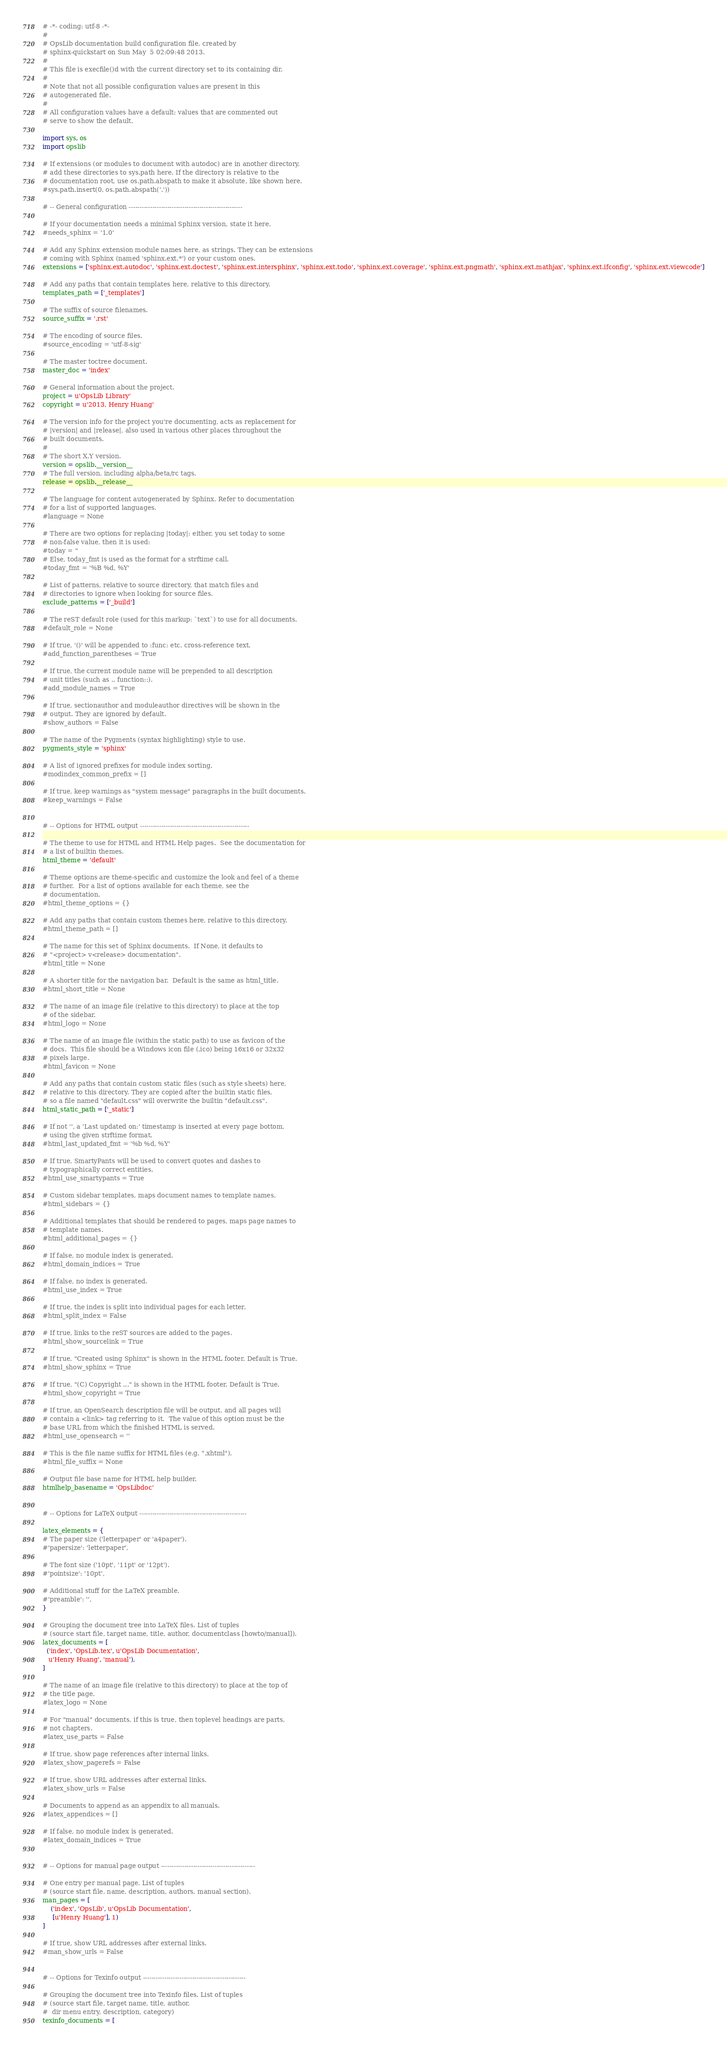<code> <loc_0><loc_0><loc_500><loc_500><_Python_># -*- coding: utf-8 -*-
#
# OpsLib documentation build configuration file, created by
# sphinx-quickstart on Sun May  5 02:09:48 2013.
#
# This file is execfile()d with the current directory set to its containing dir.
#
# Note that not all possible configuration values are present in this
# autogenerated file.
#
# All configuration values have a default; values that are commented out
# serve to show the default.

import sys, os
import opslib

# If extensions (or modules to document with autodoc) are in another directory,
# add these directories to sys.path here. If the directory is relative to the
# documentation root, use os.path.abspath to make it absolute, like shown here.
#sys.path.insert(0, os.path.abspath('.'))

# -- General configuration -----------------------------------------------------

# If your documentation needs a minimal Sphinx version, state it here.
#needs_sphinx = '1.0'

# Add any Sphinx extension module names here, as strings. They can be extensions
# coming with Sphinx (named 'sphinx.ext.*') or your custom ones.
extensions = ['sphinx.ext.autodoc', 'sphinx.ext.doctest', 'sphinx.ext.intersphinx', 'sphinx.ext.todo', 'sphinx.ext.coverage', 'sphinx.ext.pngmath', 'sphinx.ext.mathjax', 'sphinx.ext.ifconfig', 'sphinx.ext.viewcode']

# Add any paths that contain templates here, relative to this directory.
templates_path = ['_templates']

# The suffix of source filenames.
source_suffix = '.rst'

# The encoding of source files.
#source_encoding = 'utf-8-sig'

# The master toctree document.
master_doc = 'index'

# General information about the project.
project = u'OpsLib Library'
copyright = u'2013, Henry Huang'

# The version info for the project you're documenting, acts as replacement for
# |version| and |release|, also used in various other places throughout the
# built documents.
#
# The short X.Y version.
version = opslib.__version__
# The full version, including alpha/beta/rc tags.
release = opslib.__release__

# The language for content autogenerated by Sphinx. Refer to documentation
# for a list of supported languages.
#language = None

# There are two options for replacing |today|: either, you set today to some
# non-false value, then it is used:
#today = ''
# Else, today_fmt is used as the format for a strftime call.
#today_fmt = '%B %d, %Y'

# List of patterns, relative to source directory, that match files and
# directories to ignore when looking for source files.
exclude_patterns = ['_build']

# The reST default role (used for this markup: `text`) to use for all documents.
#default_role = None

# If true, '()' will be appended to :func: etc. cross-reference text.
#add_function_parentheses = True

# If true, the current module name will be prepended to all description
# unit titles (such as .. function::).
#add_module_names = True

# If true, sectionauthor and moduleauthor directives will be shown in the
# output. They are ignored by default.
#show_authors = False

# The name of the Pygments (syntax highlighting) style to use.
pygments_style = 'sphinx'

# A list of ignored prefixes for module index sorting.
#modindex_common_prefix = []

# If true, keep warnings as "system message" paragraphs in the built documents.
#keep_warnings = False


# -- Options for HTML output ---------------------------------------------------

# The theme to use for HTML and HTML Help pages.  See the documentation for
# a list of builtin themes.
html_theme = 'default'

# Theme options are theme-specific and customize the look and feel of a theme
# further.  For a list of options available for each theme, see the
# documentation.
#html_theme_options = {}

# Add any paths that contain custom themes here, relative to this directory.
#html_theme_path = []

# The name for this set of Sphinx documents.  If None, it defaults to
# "<project> v<release> documentation".
#html_title = None

# A shorter title for the navigation bar.  Default is the same as html_title.
#html_short_title = None

# The name of an image file (relative to this directory) to place at the top
# of the sidebar.
#html_logo = None

# The name of an image file (within the static path) to use as favicon of the
# docs.  This file should be a Windows icon file (.ico) being 16x16 or 32x32
# pixels large.
#html_favicon = None

# Add any paths that contain custom static files (such as style sheets) here,
# relative to this directory. They are copied after the builtin static files,
# so a file named "default.css" will overwrite the builtin "default.css".
html_static_path = ['_static']

# If not '', a 'Last updated on:' timestamp is inserted at every page bottom,
# using the given strftime format.
#html_last_updated_fmt = '%b %d, %Y'

# If true, SmartyPants will be used to convert quotes and dashes to
# typographically correct entities.
#html_use_smartypants = True

# Custom sidebar templates, maps document names to template names.
#html_sidebars = {}

# Additional templates that should be rendered to pages, maps page names to
# template names.
#html_additional_pages = {}

# If false, no module index is generated.
#html_domain_indices = True

# If false, no index is generated.
#html_use_index = True

# If true, the index is split into individual pages for each letter.
#html_split_index = False

# If true, links to the reST sources are added to the pages.
#html_show_sourcelink = True

# If true, "Created using Sphinx" is shown in the HTML footer. Default is True.
#html_show_sphinx = True

# If true, "(C) Copyright ..." is shown in the HTML footer. Default is True.
#html_show_copyright = True

# If true, an OpenSearch description file will be output, and all pages will
# contain a <link> tag referring to it.  The value of this option must be the
# base URL from which the finished HTML is served.
#html_use_opensearch = ''

# This is the file name suffix for HTML files (e.g. ".xhtml").
#html_file_suffix = None

# Output file base name for HTML help builder.
htmlhelp_basename = 'OpsLibdoc'


# -- Options for LaTeX output --------------------------------------------------

latex_elements = {
# The paper size ('letterpaper' or 'a4paper').
#'papersize': 'letterpaper',

# The font size ('10pt', '11pt' or '12pt').
#'pointsize': '10pt',

# Additional stuff for the LaTeX preamble.
#'preamble': '',
}

# Grouping the document tree into LaTeX files. List of tuples
# (source start file, target name, title, author, documentclass [howto/manual]).
latex_documents = [
  ('index', 'OpsLib.tex', u'OpsLib Documentation',
   u'Henry Huang', 'manual'),
]

# The name of an image file (relative to this directory) to place at the top of
# the title page.
#latex_logo = None

# For "manual" documents, if this is true, then toplevel headings are parts,
# not chapters.
#latex_use_parts = False

# If true, show page references after internal links.
#latex_show_pagerefs = False

# If true, show URL addresses after external links.
#latex_show_urls = False

# Documents to append as an appendix to all manuals.
#latex_appendices = []

# If false, no module index is generated.
#latex_domain_indices = True


# -- Options for manual page output --------------------------------------------

# One entry per manual page. List of tuples
# (source start file, name, description, authors, manual section).
man_pages = [
    ('index', 'OpsLib', u'OpsLib Documentation',
     [u'Henry Huang'], 1)
]

# If true, show URL addresses after external links.
#man_show_urls = False


# -- Options for Texinfo output ------------------------------------------------

# Grouping the document tree into Texinfo files. List of tuples
# (source start file, target name, title, author,
#  dir menu entry, description, category)
texinfo_documents = [</code> 